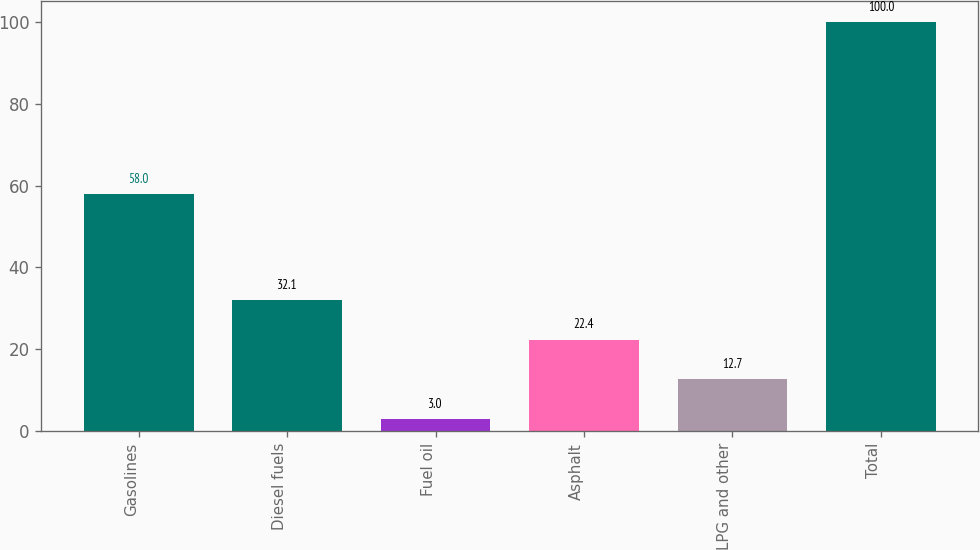<chart> <loc_0><loc_0><loc_500><loc_500><bar_chart><fcel>Gasolines<fcel>Diesel fuels<fcel>Fuel oil<fcel>Asphalt<fcel>LPG and other<fcel>Total<nl><fcel>58<fcel>32.1<fcel>3<fcel>22.4<fcel>12.7<fcel>100<nl></chart> 